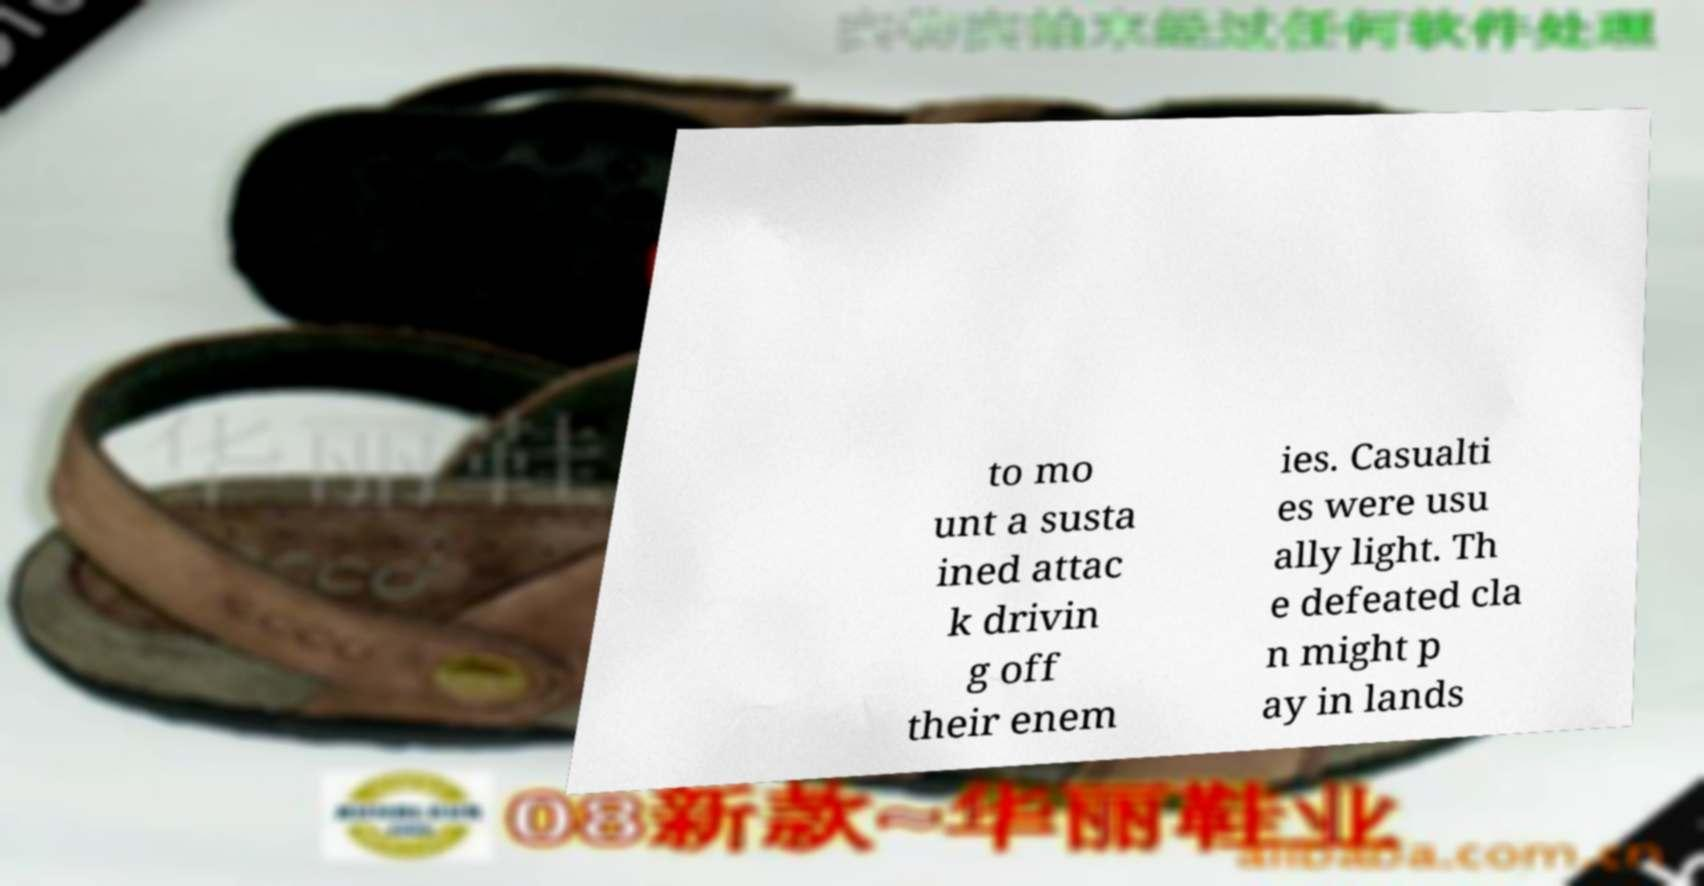Please read and relay the text visible in this image. What does it say? to mo unt a susta ined attac k drivin g off their enem ies. Casualti es were usu ally light. Th e defeated cla n might p ay in lands 